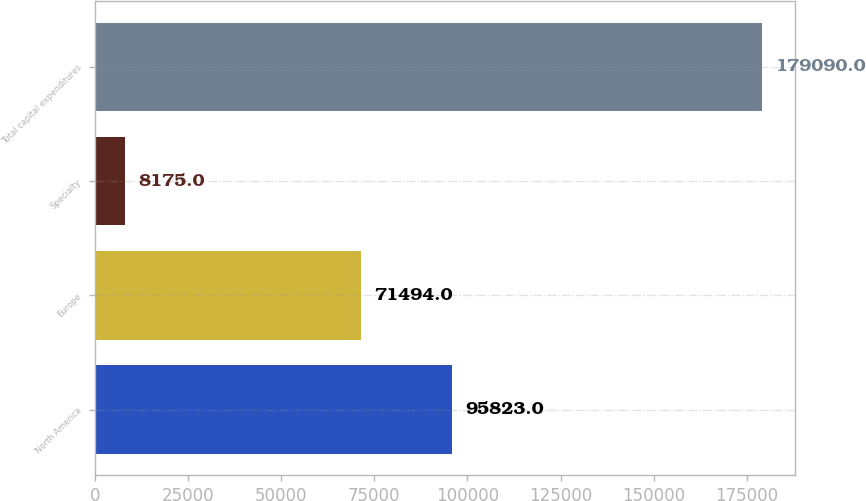Convert chart. <chart><loc_0><loc_0><loc_500><loc_500><bar_chart><fcel>North America<fcel>Europe<fcel>Specialty<fcel>Total capital expenditures<nl><fcel>95823<fcel>71494<fcel>8175<fcel>179090<nl></chart> 